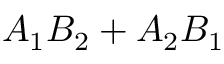Convert formula to latex. <formula><loc_0><loc_0><loc_500><loc_500>A _ { 1 } B _ { 2 } + A _ { 2 } B _ { 1 }</formula> 